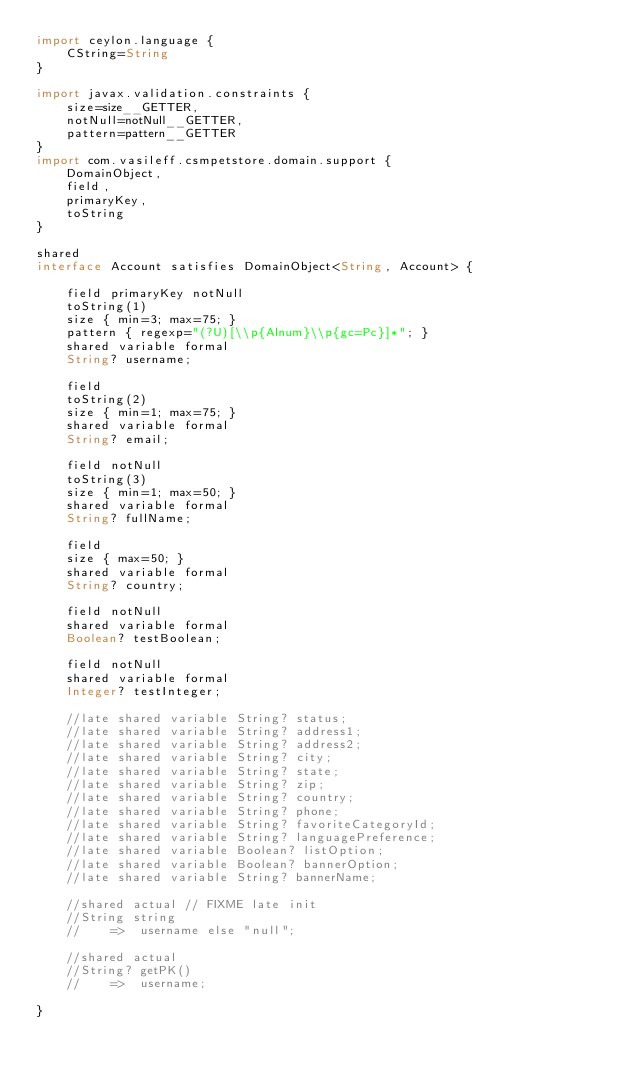<code> <loc_0><loc_0><loc_500><loc_500><_Ceylon_>import ceylon.language {
    CString=String
}

import javax.validation.constraints {
    size=size__GETTER,
    notNull=notNull__GETTER,
    pattern=pattern__GETTER
}
import com.vasileff.csmpetstore.domain.support {
    DomainObject,
    field,
    primaryKey,
    toString
}

shared
interface Account satisfies DomainObject<String, Account> {

    field primaryKey notNull
    toString(1)
    size { min=3; max=75; }
    pattern { regexp="(?U)[\\p{Alnum}\\p{gc=Pc}]*"; }
    shared variable formal
    String? username;

    field
    toString(2)
    size { min=1; max=75; }
    shared variable formal
    String? email;

    field notNull
    toString(3)
    size { min=1; max=50; }
    shared variable formal
    String? fullName;

    field
    size { max=50; }
    shared variable formal
    String? country;

    field notNull
    shared variable formal
    Boolean? testBoolean;

    field notNull
    shared variable formal
    Integer? testInteger;

    //late shared variable String? status;
    //late shared variable String? address1;
    //late shared variable String? address2;
    //late shared variable String? city;
    //late shared variable String? state;
    //late shared variable String? zip;
    //late shared variable String? country;
    //late shared variable String? phone;
    //late shared variable String? favoriteCategoryId;
    //late shared variable String? languagePreference;
    //late shared variable Boolean? listOption;
    //late shared variable Boolean? bannerOption;
    //late shared variable String? bannerName;

    //shared actual // FIXME late init
    //String string
    //    =>  username else "null";

    //shared actual
    //String? getPK()
    //    =>  username;

}
</code> 